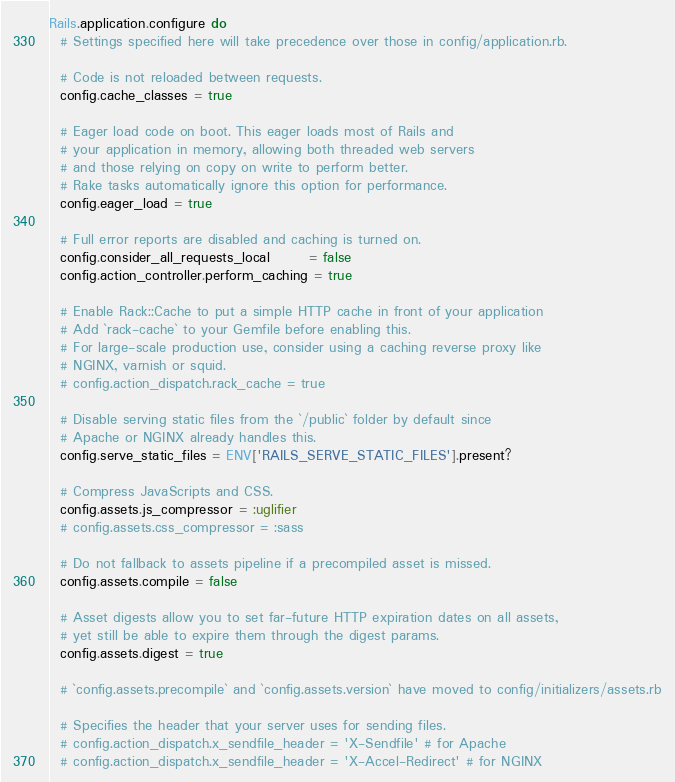Convert code to text. <code><loc_0><loc_0><loc_500><loc_500><_Ruby_>Rails.application.configure do
  # Settings specified here will take precedence over those in config/application.rb.

  # Code is not reloaded between requests.
  config.cache_classes = true

  # Eager load code on boot. This eager loads most of Rails and
  # your application in memory, allowing both threaded web servers
  # and those relying on copy on write to perform better.
  # Rake tasks automatically ignore this option for performance.
  config.eager_load = true

  # Full error reports are disabled and caching is turned on.
  config.consider_all_requests_local       = false
  config.action_controller.perform_caching = true

  # Enable Rack::Cache to put a simple HTTP cache in front of your application
  # Add `rack-cache` to your Gemfile before enabling this.
  # For large-scale production use, consider using a caching reverse proxy like
  # NGINX, varnish or squid.
  # config.action_dispatch.rack_cache = true

  # Disable serving static files from the `/public` folder by default since
  # Apache or NGINX already handles this.
  config.serve_static_files = ENV['RAILS_SERVE_STATIC_FILES'].present?

  # Compress JavaScripts and CSS.
  config.assets.js_compressor = :uglifier
  # config.assets.css_compressor = :sass

  # Do not fallback to assets pipeline if a precompiled asset is missed.
  config.assets.compile = false

  # Asset digests allow you to set far-future HTTP expiration dates on all assets,
  # yet still be able to expire them through the digest params.
  config.assets.digest = true

  # `config.assets.precompile` and `config.assets.version` have moved to config/initializers/assets.rb

  # Specifies the header that your server uses for sending files.
  # config.action_dispatch.x_sendfile_header = 'X-Sendfile' # for Apache
  # config.action_dispatch.x_sendfile_header = 'X-Accel-Redirect' # for NGINX
</code> 